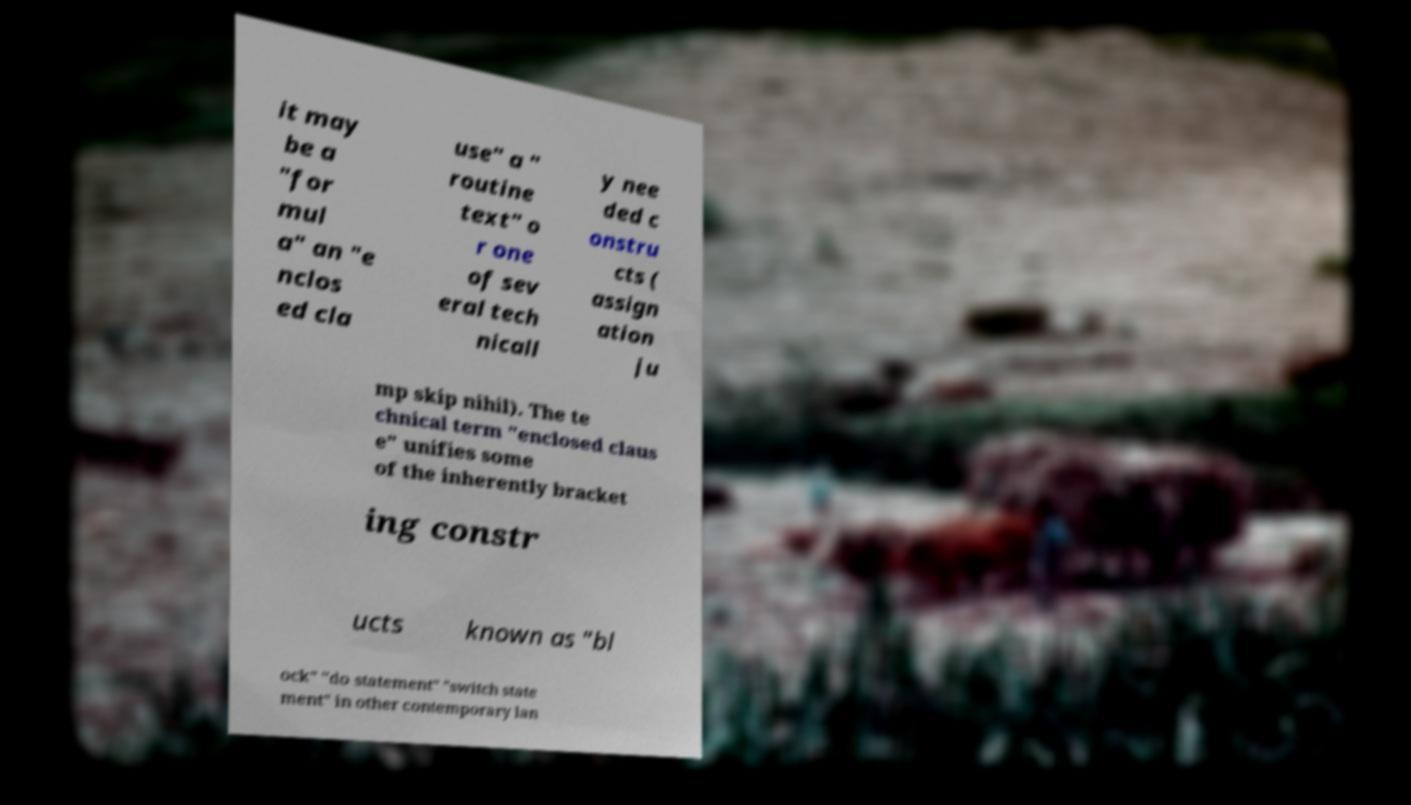What messages or text are displayed in this image? I need them in a readable, typed format. it may be a "for mul a" an "e nclos ed cla use" a " routine text" o r one of sev eral tech nicall y nee ded c onstru cts ( assign ation ju mp skip nihil). The te chnical term "enclosed claus e" unifies some of the inherently bracket ing constr ucts known as "bl ock" "do statement" "switch state ment" in other contemporary lan 